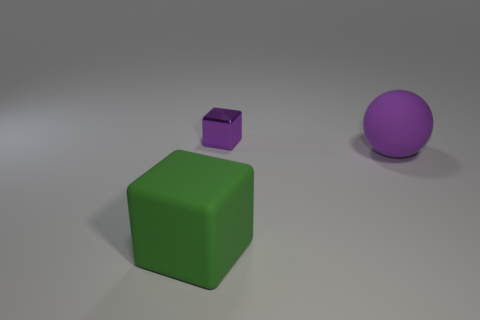What shape is the large object that is the same material as the green cube?
Make the answer very short. Sphere. What number of tiny things are blue rubber balls or metallic cubes?
Keep it short and to the point. 1. What number of other objects are there of the same color as the small block?
Give a very brief answer. 1. How many matte objects are right of the purple thing behind the rubber thing on the right side of the large green cube?
Offer a very short reply. 1. There is a object that is to the left of the metallic object; is its size the same as the big purple matte thing?
Offer a terse response. Yes. Is the number of matte spheres to the left of the purple metal thing less than the number of large matte objects left of the big matte ball?
Provide a short and direct response. Yes. Is the small metallic thing the same color as the ball?
Offer a very short reply. Yes. Is the number of purple things in front of the purple matte object less than the number of yellow cubes?
Give a very brief answer. No. There is a object that is the same color as the large rubber ball; what is it made of?
Provide a short and direct response. Metal. Is the material of the small cube the same as the big purple sphere?
Offer a very short reply. No. 